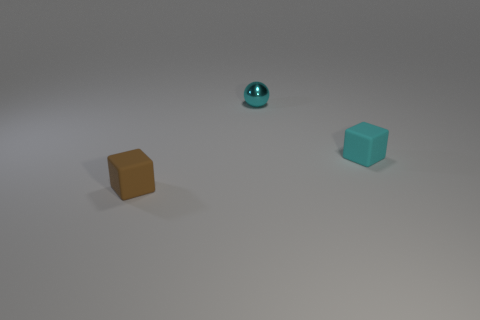Add 2 big brown metallic spheres. How many objects exist? 5 Subtract all balls. How many objects are left? 2 Add 2 small metallic objects. How many small metallic objects are left? 3 Add 3 rubber blocks. How many rubber blocks exist? 5 Subtract 0 purple balls. How many objects are left? 3 Subtract all small objects. Subtract all cyan metal cubes. How many objects are left? 0 